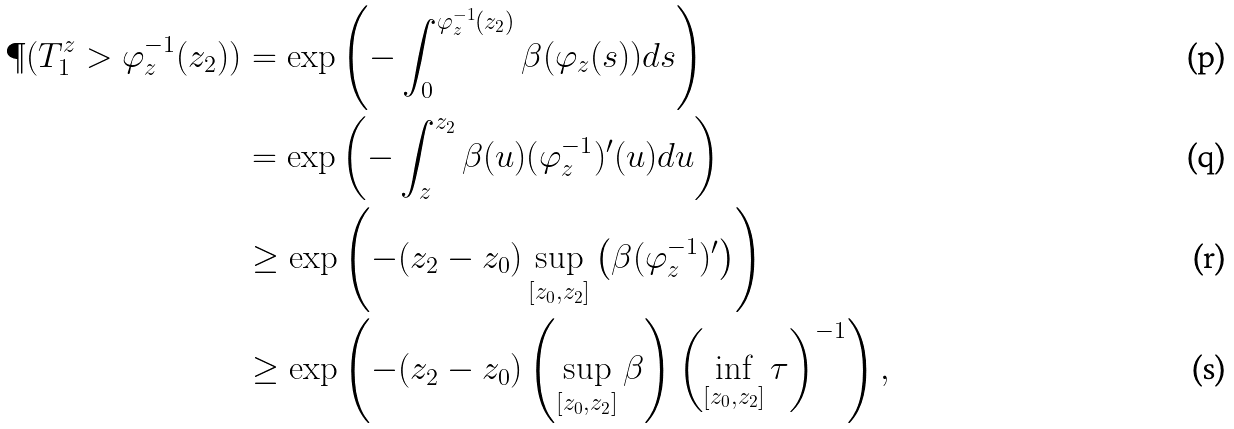Convert formula to latex. <formula><loc_0><loc_0><loc_500><loc_500>\P ( T _ { 1 } ^ { z } > \varphi _ { z } ^ { - 1 } ( z _ { 2 } ) ) & = \exp \left ( - \int _ { 0 } ^ { \varphi _ { z } ^ { - 1 } ( z _ { 2 } ) } \beta ( \varphi _ { z } ( s ) ) d s \right ) \\ & = \exp \left ( - \int _ { z } ^ { z _ { 2 } } \beta ( u ) ( \varphi _ { z } ^ { - 1 } ) ^ { \prime } ( u ) d u \right ) \\ & \geq \exp \left ( - ( z _ { 2 } - z _ { 0 } ) \sup _ { [ z _ { 0 } , z _ { 2 } ] } \left ( \beta ( \varphi _ { z } ^ { - 1 } ) ^ { \prime } \right ) \right ) \\ & \geq \exp \left ( - ( z _ { 2 } - z _ { 0 } ) \left ( \sup _ { [ z _ { 0 } , z _ { 2 } ] } \beta \right ) \left ( \inf _ { [ z _ { 0 } , z _ { 2 } ] } \tau \right ) ^ { - 1 } \right ) ,</formula> 